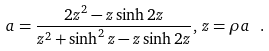Convert formula to latex. <formula><loc_0><loc_0><loc_500><loc_500>a = \frac { 2 z ^ { 2 } - z \sinh 2 z } { z ^ { 2 } + \sinh ^ { 2 } z - z \sinh 2 z } , \, z = \rho a \ .</formula> 